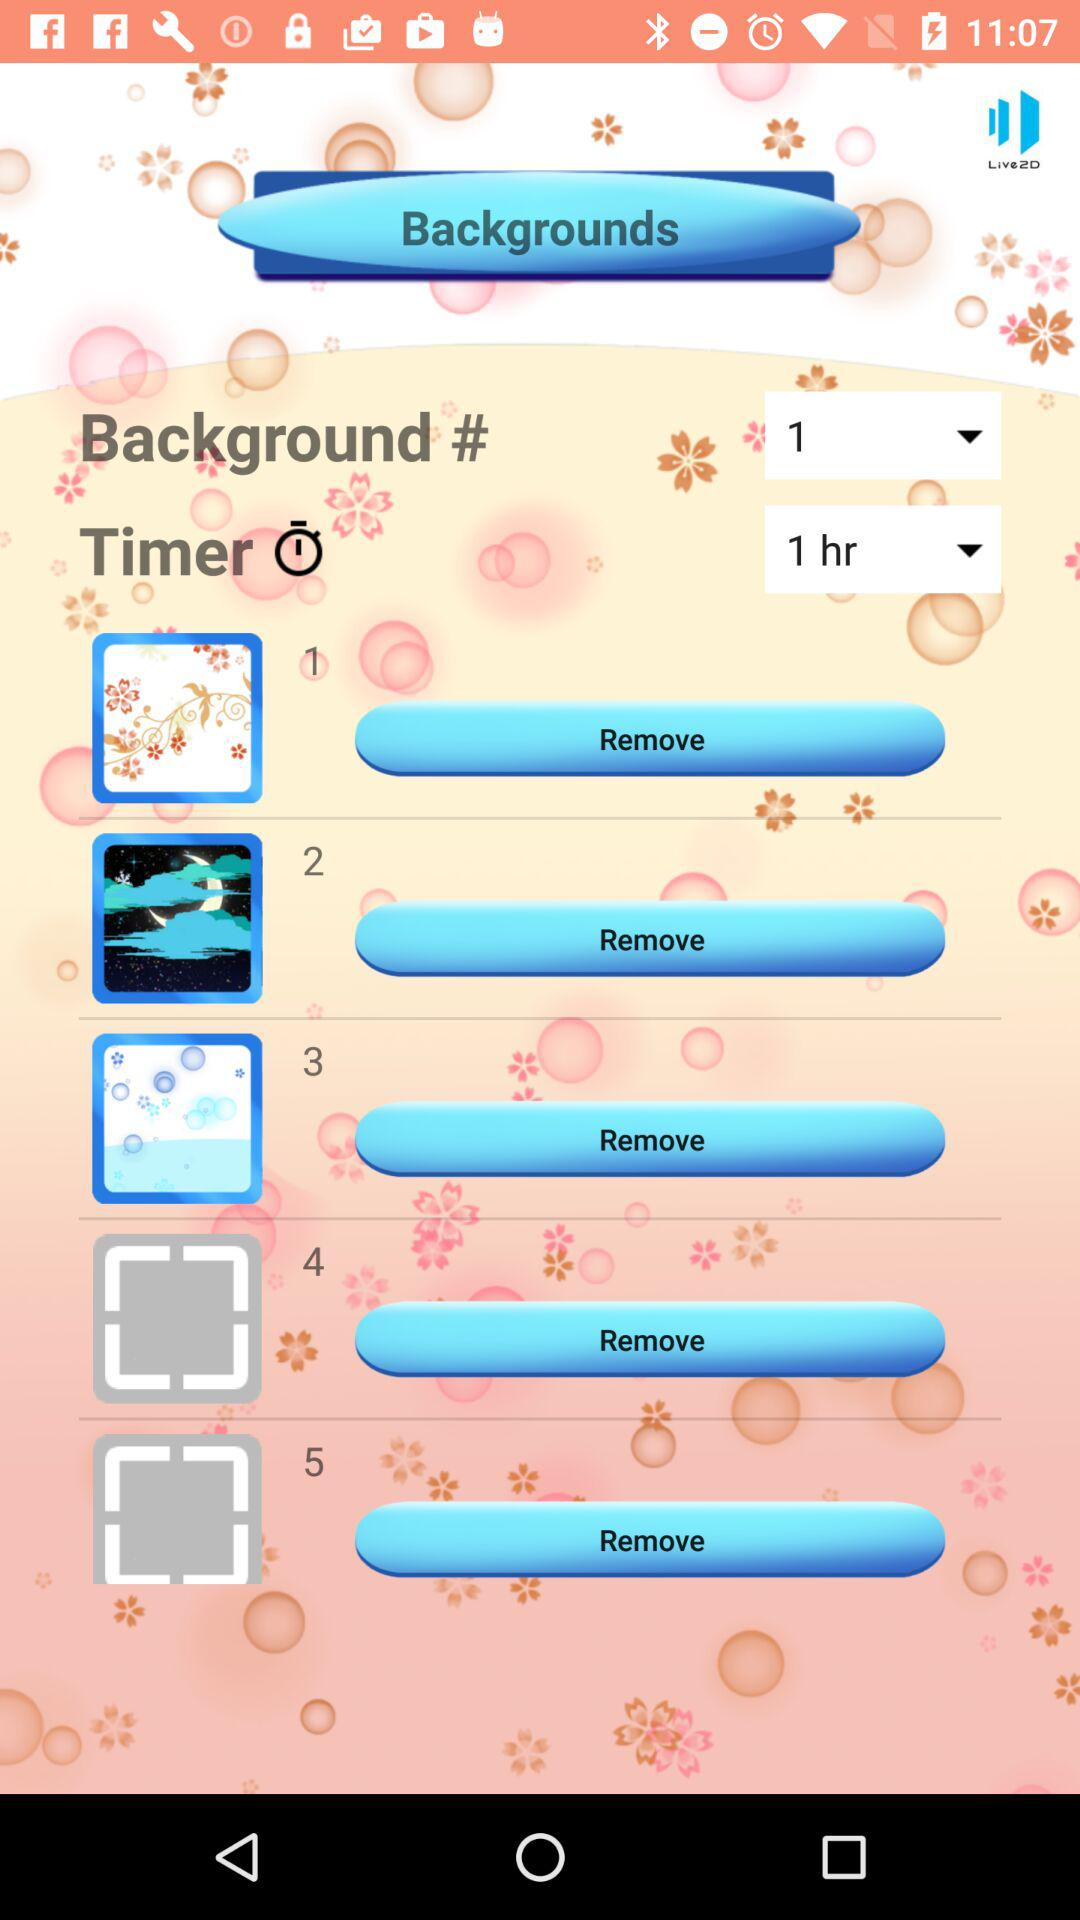What is the selected time on the timer? The selected time is 1 hour. 